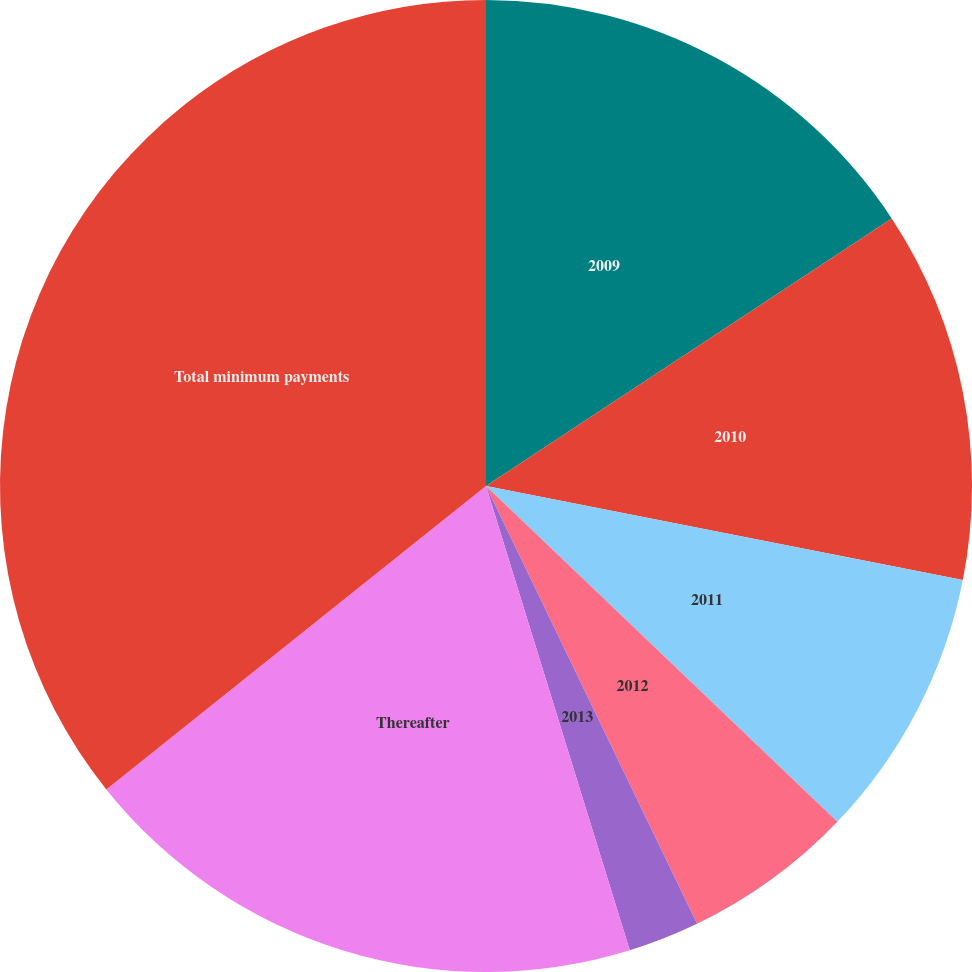Convert chart. <chart><loc_0><loc_0><loc_500><loc_500><pie_chart><fcel>2009<fcel>2010<fcel>2011<fcel>2012<fcel>2013<fcel>Thereafter<fcel>Total minimum payments<nl><fcel>15.72%<fcel>12.38%<fcel>9.04%<fcel>5.71%<fcel>2.37%<fcel>19.05%<fcel>35.73%<nl></chart> 